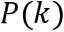Convert formula to latex. <formula><loc_0><loc_0><loc_500><loc_500>P ( k )</formula> 